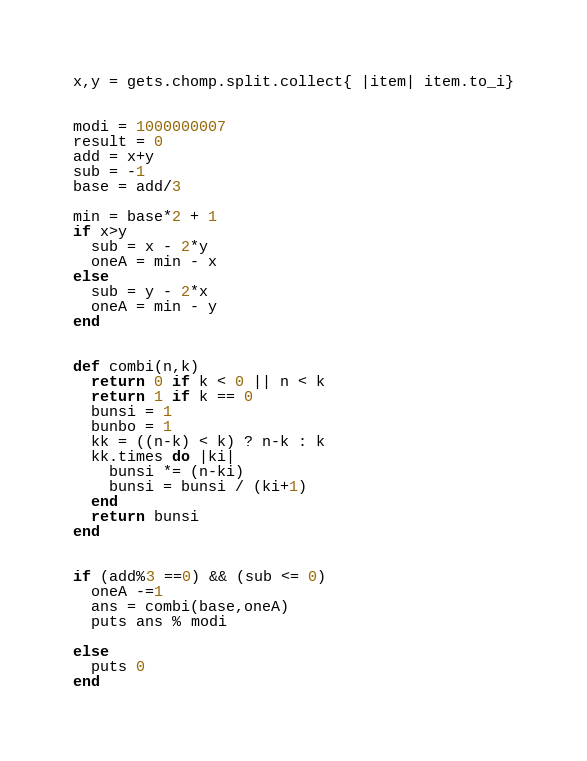<code> <loc_0><loc_0><loc_500><loc_500><_Ruby_>x,y = gets.chomp.split.collect{ |item| item.to_i}


modi = 1000000007
result = 0
add = x+y
sub = -1
base = add/3

min = base*2 + 1
if x>y
  sub = x - 2*y
  oneA = min - x
else
  sub = y - 2*x
  oneA = min - y
end


def combi(n,k)
  return 0 if k < 0 || n < k
  return 1 if k == 0
  bunsi = 1
  bunbo = 1
  kk = ((n-k) < k) ? n-k : k
  kk.times do |ki|
    bunsi *= (n-ki)
    bunsi = bunsi / (ki+1)
  end
  return bunsi
end


if (add%3 ==0) && (sub <= 0)
  oneA -=1
  ans = combi(base,oneA)
  puts ans % modi

else
  puts 0
end
</code> 